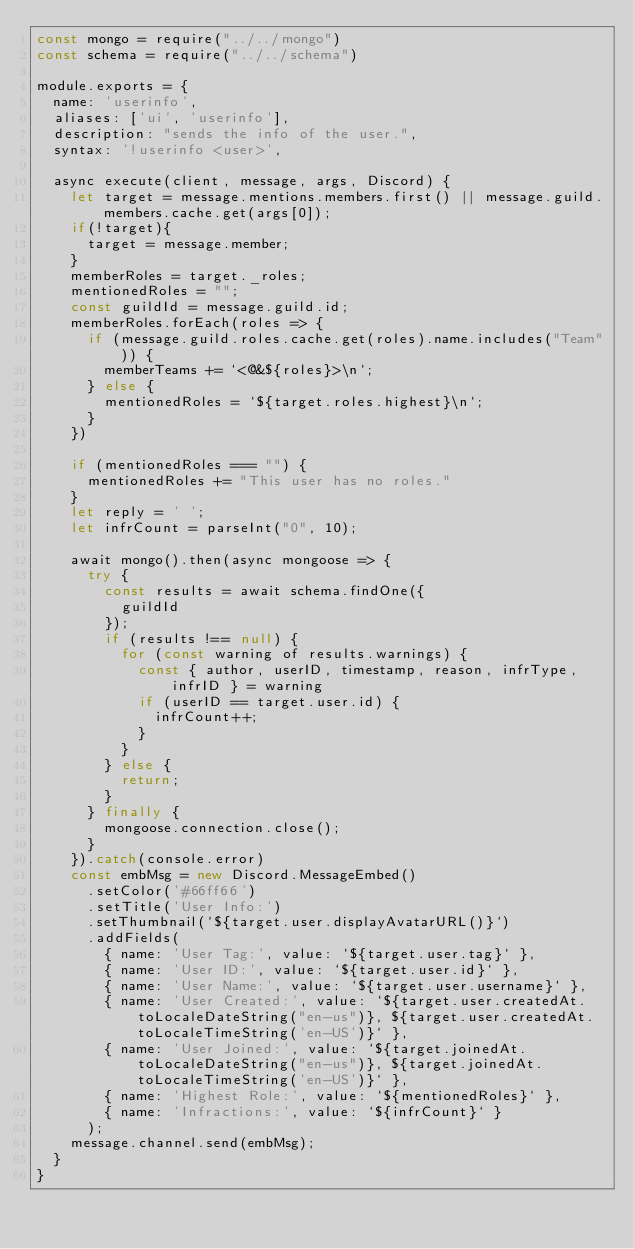<code> <loc_0><loc_0><loc_500><loc_500><_JavaScript_>const mongo = require("../../mongo")
const schema = require("../../schema")

module.exports = {
  name: 'userinfo',
  aliases: ['ui', 'userinfo'],
  description: "sends the info of the user.",
  syntax: '!userinfo <user>',

  async execute(client, message, args, Discord) {
    let target = message.mentions.members.first() || message.guild.members.cache.get(args[0]);
    if(!target){
      target = message.member;
    }
    memberRoles = target._roles;
    mentionedRoles = "";
    const guildId = message.guild.id;
    memberRoles.forEach(roles => {
      if (message.guild.roles.cache.get(roles).name.includes("Team")) {
        memberTeams += `<@&${roles}>\n`;
      } else {
        mentionedRoles = `${target.roles.highest}\n`;
      }
    })

    if (mentionedRoles === "") {
      mentionedRoles += "This user has no roles."
    }
    let reply = ' ';
    let infrCount = parseInt("0", 10);

    await mongo().then(async mongoose => {
      try {
        const results = await schema.findOne({
          guildId
        });
        if (results !== null) {
          for (const warning of results.warnings) {
            const { author, userID, timestamp, reason, infrType, infrID } = warning
            if (userID == target.user.id) {
              infrCount++;
            }
          }
        } else {
          return;
        }
      } finally {
        mongoose.connection.close();
      }
    }).catch(console.error)
    const embMsg = new Discord.MessageEmbed()
      .setColor('#66ff66')
      .setTitle('User Info:')
      .setThumbnail(`${target.user.displayAvatarURL()}`)
      .addFields(
        { name: 'User Tag:', value: `${target.user.tag}` },
        { name: 'User ID:', value: `${target.user.id}` },
        { name: 'User Name:', value: `${target.user.username}` },
        { name: 'User Created:', value: `${target.user.createdAt.toLocaleDateString("en-us")}, ${target.user.createdAt.toLocaleTimeString('en-US')}` },
        { name: 'User Joined:', value: `${target.joinedAt.toLocaleDateString("en-us")}, ${target.joinedAt.toLocaleTimeString('en-US')}` },
        { name: 'Highest Role:', value: `${mentionedRoles}` },
        { name: 'Infractions:', value: `${infrCount}` }
      );
    message.channel.send(embMsg);
  }
}
</code> 